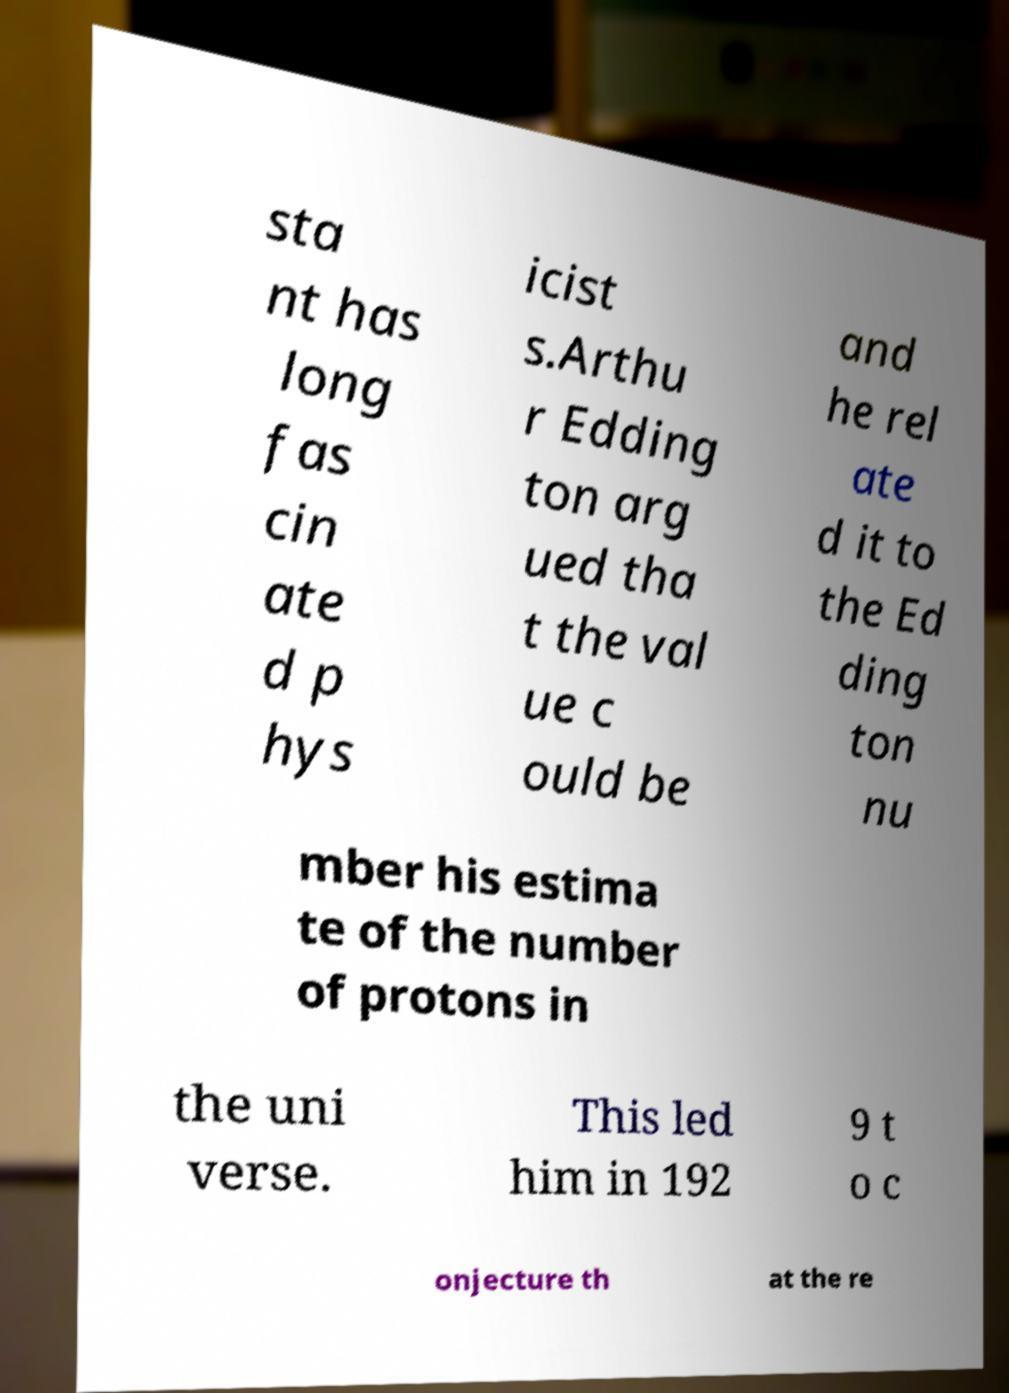Please read and relay the text visible in this image. What does it say? sta nt has long fas cin ate d p hys icist s.Arthu r Edding ton arg ued tha t the val ue c ould be and he rel ate d it to the Ed ding ton nu mber his estima te of the number of protons in the uni verse. This led him in 192 9 t o c onjecture th at the re 